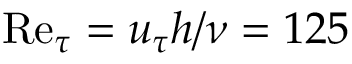Convert formula to latex. <formula><loc_0><loc_0><loc_500><loc_500>R e _ { \tau } = u _ { \tau } h / \nu = 1 2 5</formula> 